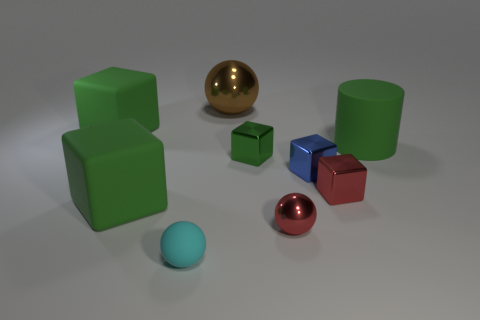Subtract all brown cylinders. How many green blocks are left? 3 Subtract all blue cubes. How many cubes are left? 4 Subtract all red metallic cubes. How many cubes are left? 4 Subtract all brown blocks. Subtract all brown spheres. How many blocks are left? 5 Add 1 gray rubber objects. How many objects exist? 10 Subtract all cubes. How many objects are left? 4 Add 4 brown objects. How many brown objects are left? 5 Add 4 small metal things. How many small metal things exist? 8 Subtract 1 cyan balls. How many objects are left? 8 Subtract all big gray matte objects. Subtract all small blue metal things. How many objects are left? 8 